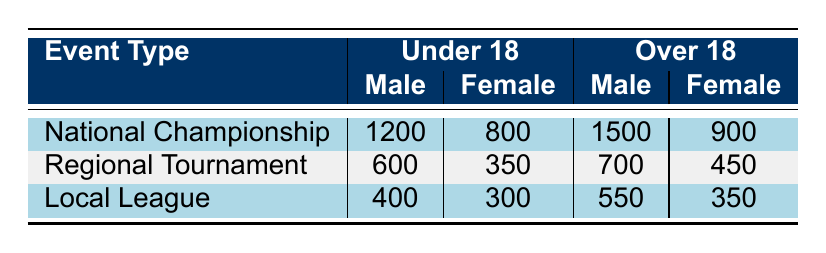What is the total attendance for the National Championship among males? The attendance for males in the National Championship is directly given in the table, which shows 1200 for Under 18 and 1500 for Over 18. Summing these values gives 1200 + 1500 = 2700.
Answer: 2700 What is the attendance for females in the Local League? The attendance for females in the Local League is directly given in the table as 300 for Under 18 and 350 for Over 18.
Answer: 300 and 350 How many more males attended the National Championship than the Regional Tournament in the Over 18 category? For the National Championship, there are 1500 males, and for the Regional Tournament, there are 700 males in the Over 18 category. Subtracting the two gives 1500 - 700 = 800.
Answer: 800 Is the attendance for females in the Under 18 age group higher at the National Championship than at the Regional Tournament? The attendance for females in the National Championship Under 18 is 800, while in the Regional Tournament it is 350. Since 800 is greater than 350, the statement is true.
Answer: Yes What is the average attendance for the Over 18 category across all event types? The attendance for males in the Over 18 category is 1500 (National Championship) + 700 (Regional Tournament) + 550 (Local League), totaling 2750. For females, it is 900 (National Championship) + 450 (Regional Tournament) + 350 (Local League), totaling 1700. The overall attendance for Over 18 is 2750 + 1700 = 4450. There are three event types, so the average is 4450 / 3 = 1483.33.
Answer: 1483.33 What is the total attendance for females in both the National Championship and Local League combined? For females in the National Championship, the attendance is 800 in Under 18 and 900 in Over 18, totaling 800 + 900 = 1700. In the Local League, the females have 300 in Under 18 and 350 in Over 18, totaling 300 + 350 = 650. Adding these two results gives 1700 + 650 = 2350.
Answer: 2350 